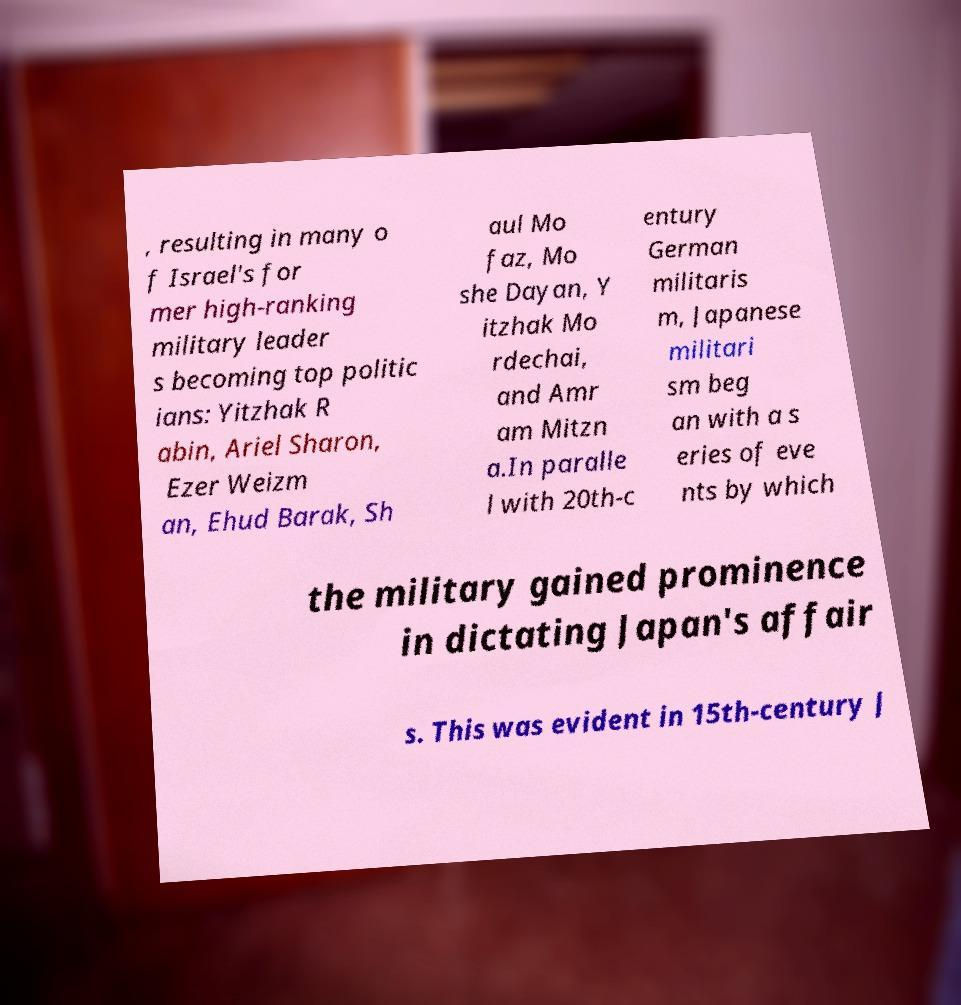I need the written content from this picture converted into text. Can you do that? , resulting in many o f Israel's for mer high-ranking military leader s becoming top politic ians: Yitzhak R abin, Ariel Sharon, Ezer Weizm an, Ehud Barak, Sh aul Mo faz, Mo she Dayan, Y itzhak Mo rdechai, and Amr am Mitzn a.In paralle l with 20th-c entury German militaris m, Japanese militari sm beg an with a s eries of eve nts by which the military gained prominence in dictating Japan's affair s. This was evident in 15th-century J 